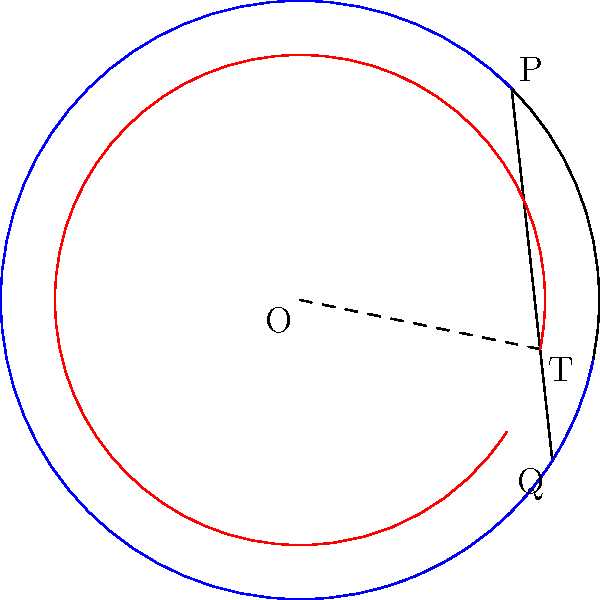Consider a vinyl record as a non-Euclidean surface. If you draw a straight line from point P to point Q passing through point T on the record's surface, the angles $\theta$ and $\phi$ are formed as shown in the diagram. In Euclidean geometry, $\theta + \phi = 180°$. However, on the curved surface of the record, this sum differs. Is the sum $\theta + \phi$ greater than, less than, or equal to 180°? Explain your reasoning using the concept of curvature. To answer this question, we need to consider the curvature of the vinyl record's surface:

1. The vinyl record has a positive curvature, meaning it bulges outward like a sphere.

2. In non-Euclidean geometry, the sum of angles in a triangle on a curved surface differs from 180°:
   - On positively curved surfaces (like a sphere or vinyl record), the sum is greater than 180°.
   - On negatively curved surfaces (like a saddle), the sum is less than 180°.

3. The line from P to Q through T forms two angles ($\theta$ and $\phi$) with the radii from the center O.

4. These angles, along with the angle at the center, form a triangle on the curved surface of the record.

5. Due to the positive curvature of the record, this triangle will have an angle sum greater than 180°.

6. Since the angle at the center remains constant (as it's not affected by the surface curvature), the increase in the angle sum must come from $\theta$ and $\phi$.

7. Therefore, the sum of $\theta$ and $\phi$ must be greater than 180° to account for the excess angle caused by the positive curvature of the record's surface.

This phenomenon is similar to what happens on the surface of the Earth, where triangles formed by great circles have angle sums greater than 180°.
Answer: Greater than 180° 